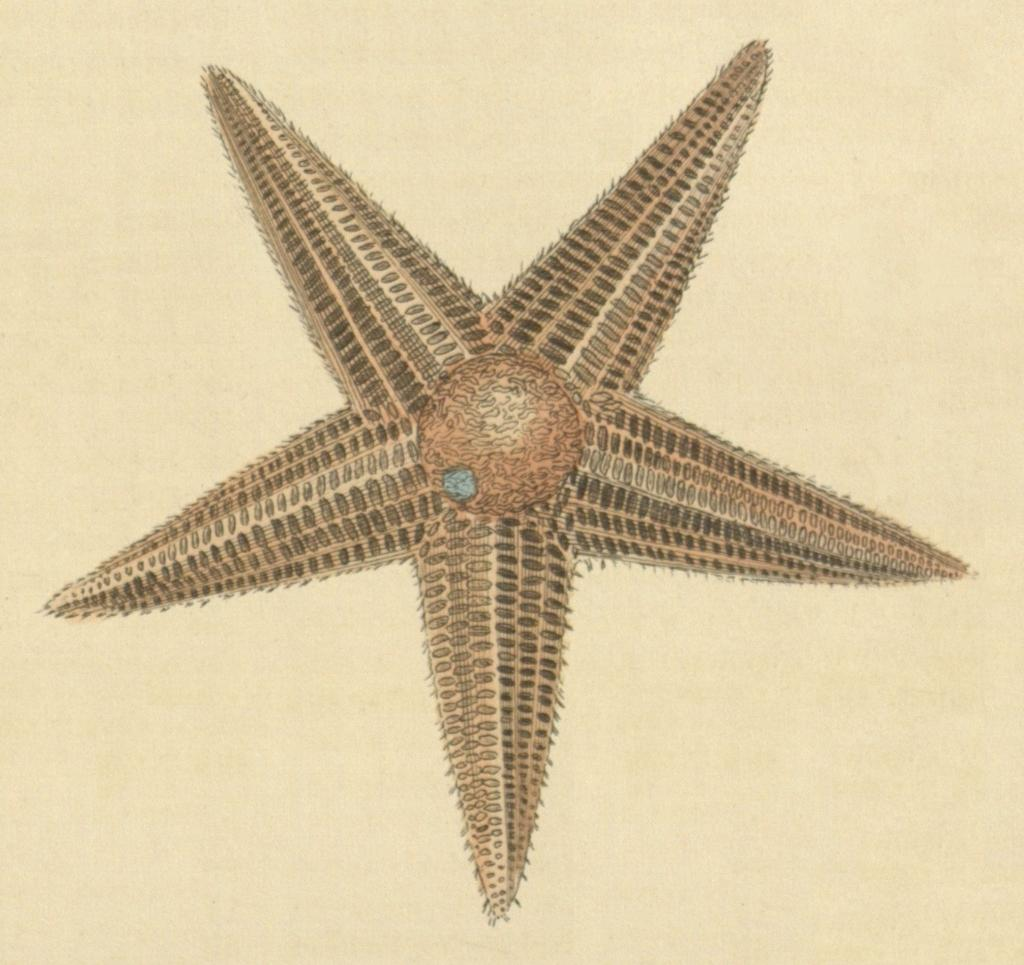What is depicted on the paper in the image? There is an image of a starfish on the paper. What type of scarecrow is standing next to the starfish in the image? There is no scarecrow present in the image; it only features an image of a starfish on the paper. How many elbows does the starfish have in the image? Starfish do not have elbows, as they are marine animals with five arms. --- Facts: 1. There is a person holding a book in the image. 2. The person is sitting on a chair. 3. The book has a blue cover. 4. The chair has a wooden frame. Absurd Topics: elephant, ocean, bicycle Conversation: What is the person in the image holding? The person in the image is holding a book. What is the person's position in the image? The person is sitting on a chair. What color is the book's cover? The book has a blue cover. What is the chair made of? The chair has a wooden frame. Reasoning: Let's think step by step in order to produce the conversation. We start by identifying the main subject in the image, which is the person holding a book. Then, we expand the conversation to include the person's position and the book's cover color. Finally, we describe the chair's frame material. Each question is designed to elicit a specific detail about the image that is known from the provided facts. Absurd Question/Answer: Can you see an elephant swimming in the ocean in the image? There is no elephant or ocean present in the image; it only features a person sitting on a chair holding a book with a blue cover. Is the person riding a bicycle in the image? There is no bicycle present in the image; it only features a person sitting on a chair holding a book with a blue cover. 